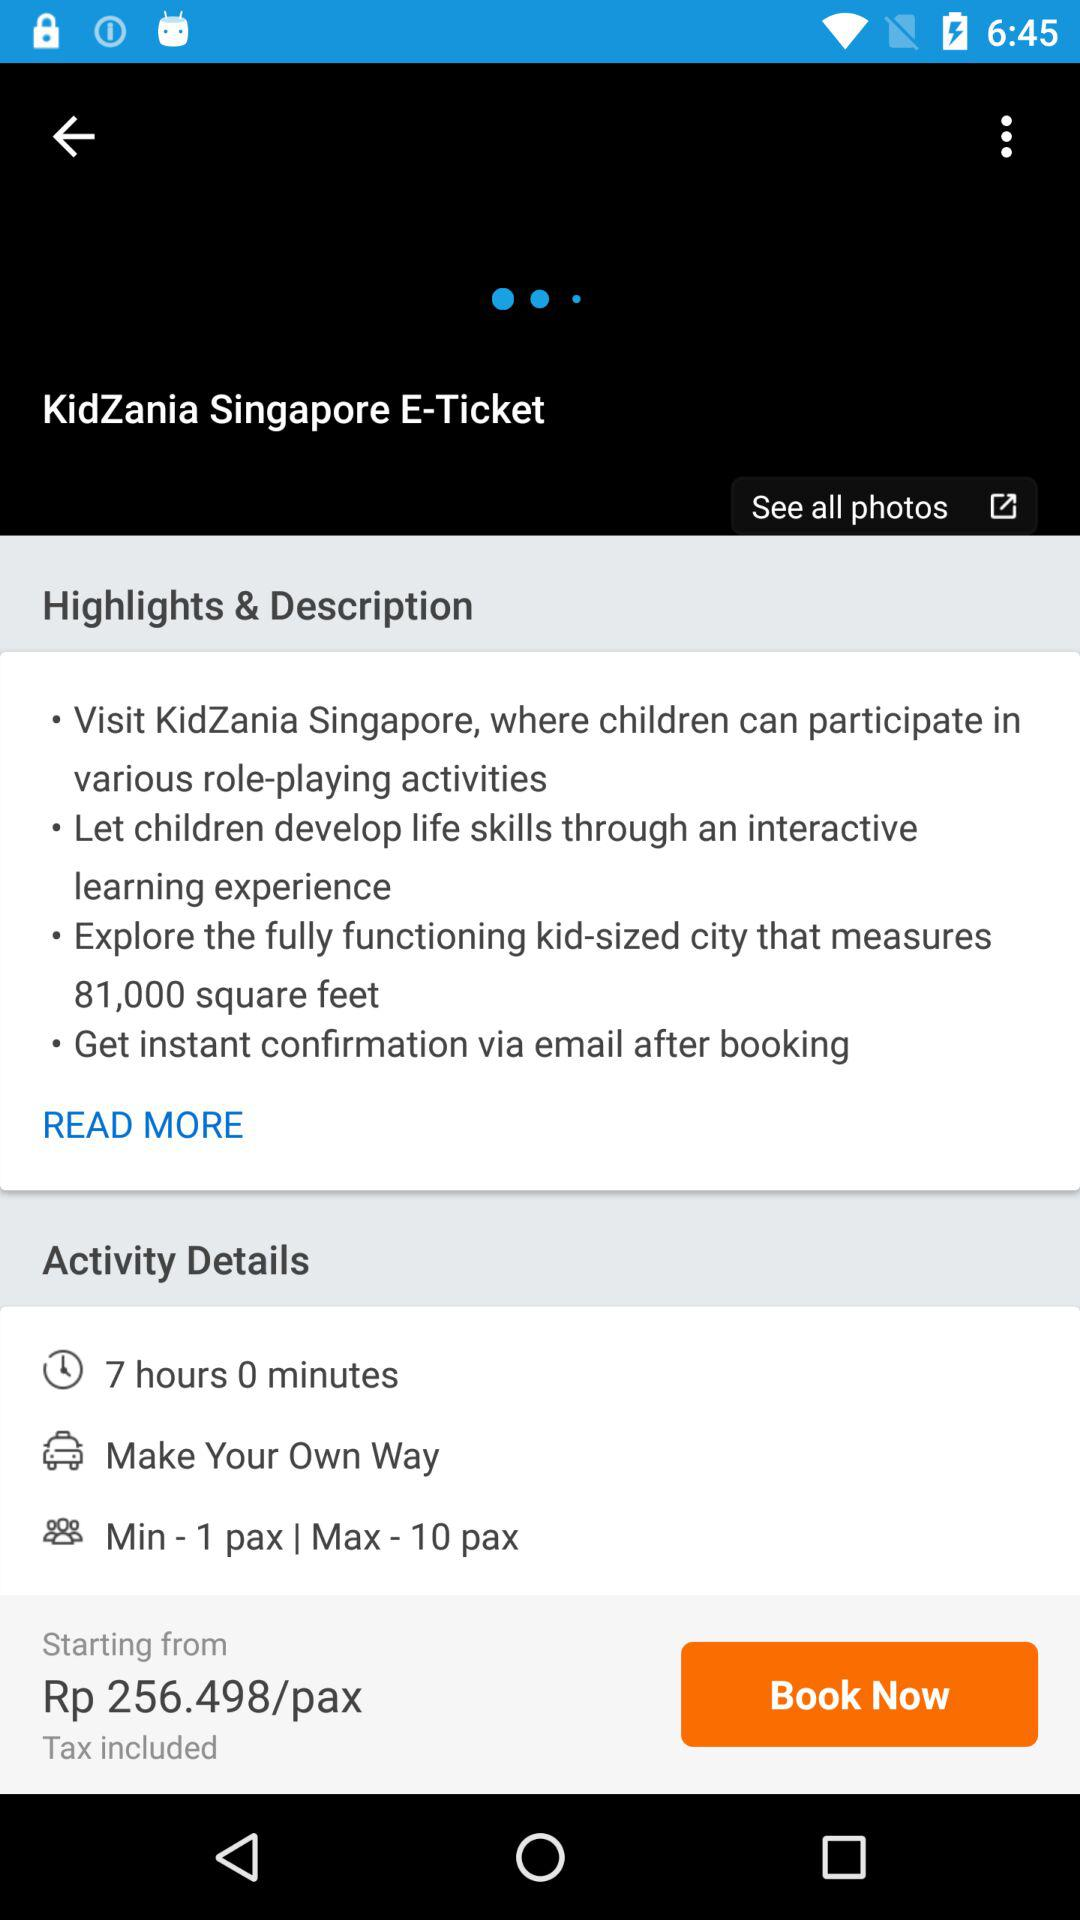How many more people can participate in this activity than the minimum number of people?
Answer the question using a single word or phrase. 9 